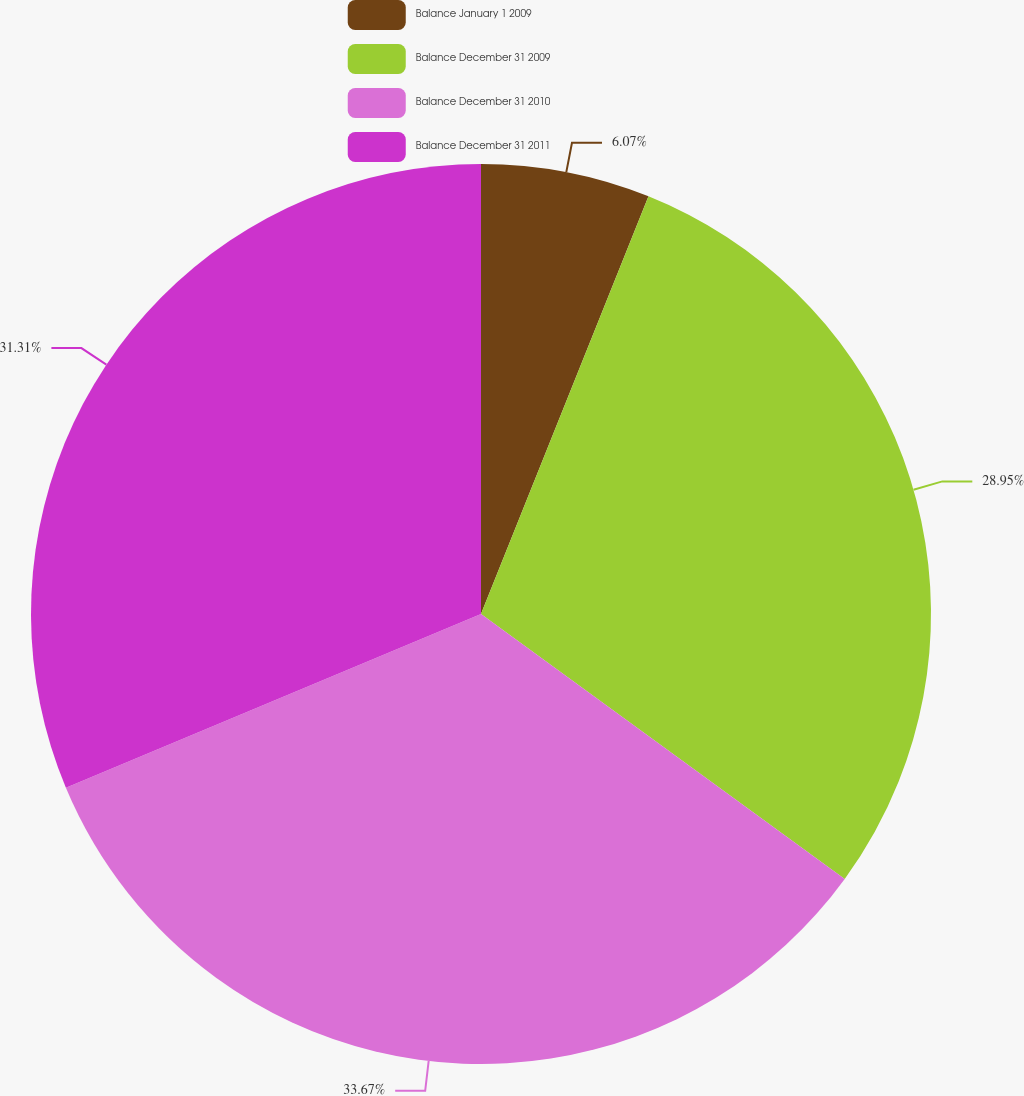Convert chart. <chart><loc_0><loc_0><loc_500><loc_500><pie_chart><fcel>Balance January 1 2009<fcel>Balance December 31 2009<fcel>Balance December 31 2010<fcel>Balance December 31 2011<nl><fcel>6.07%<fcel>28.95%<fcel>33.67%<fcel>31.31%<nl></chart> 